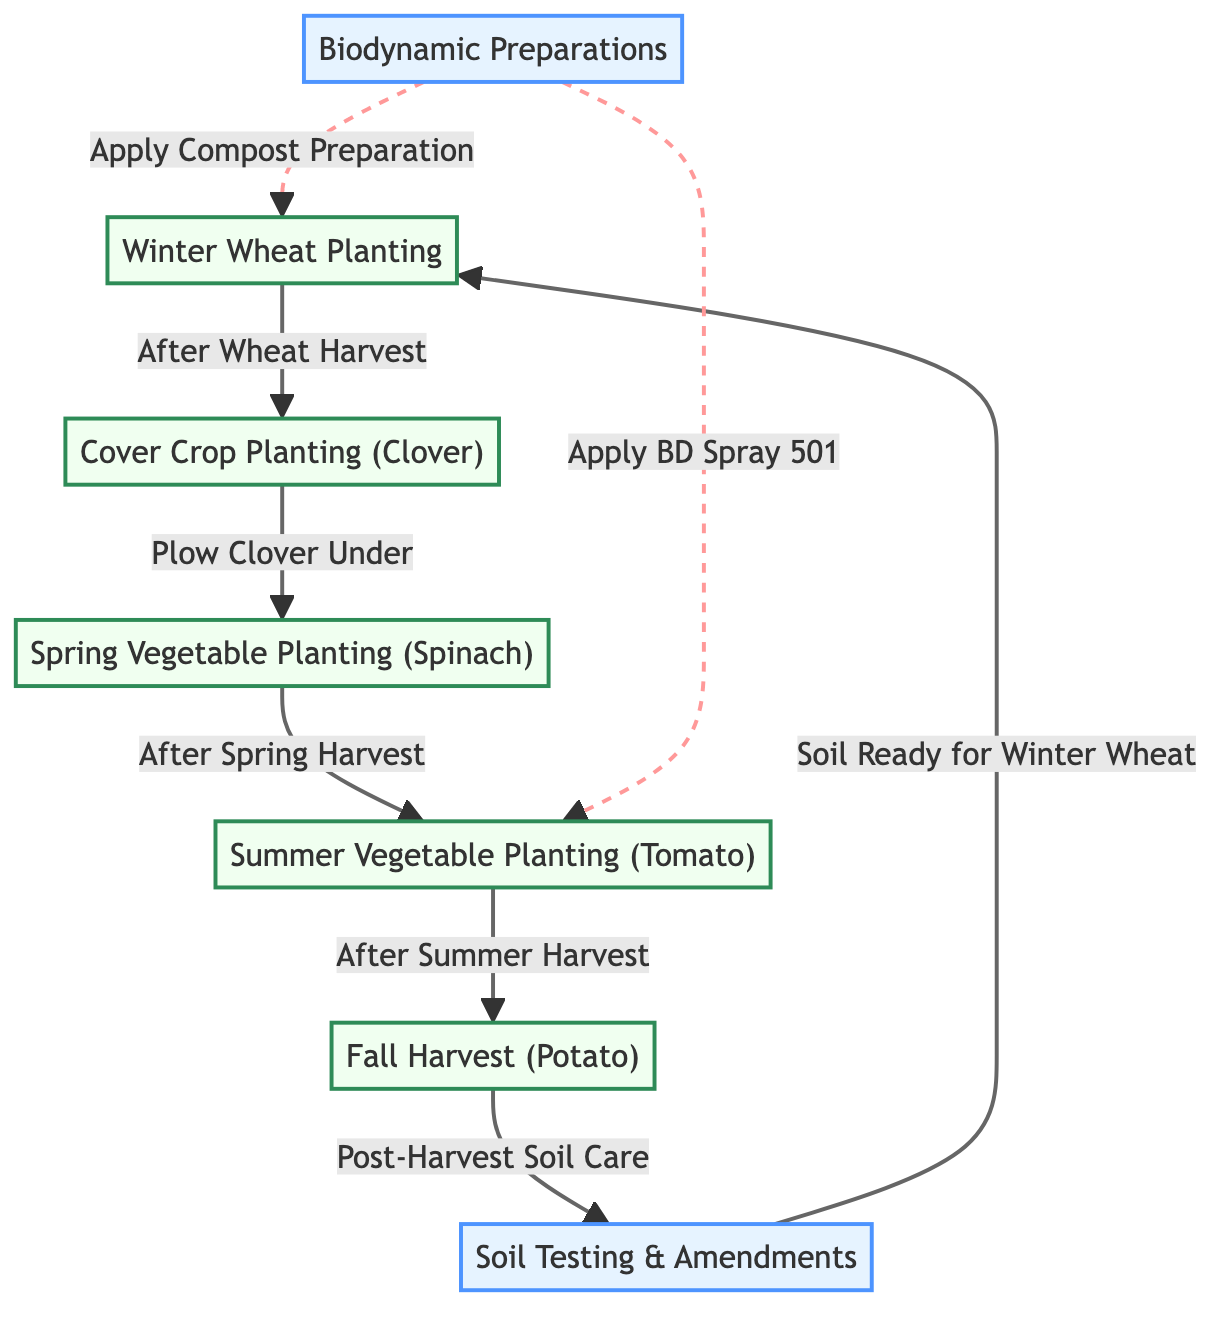What is the first crop planted in the rotation? The graph indicates that the first node in the cycle is "Winter Wheat Planting," which appears at the beginning of the flow.
Answer: Winter Wheat Planting How many nodes are there in the diagram? Counting all unique nodes presented in the data, we see there are seven nodes.
Answer: 7 What follows "Cover Crop Planting (Clover)" in the sequence? The directed edge labeled "Plow Clover Under" leads from "Cover Crop Planting (Clover)" to "Spring Vegetable Planting (Spinach)," indicating this is the next step.
Answer: Spring Vegetable Planting (Spinach) What is applied after "Summer Vegetable Planting (Tomato)"? Based on the directed edge labeled "After Summer Harvest," it transitions to "Fall Harvest (Potato)," indicating this is the subsequent action.
Answer: Fall Harvest (Potato) Identify the preparation step related to soil care. The directed edge labeled "Post-Harvest Soil Care" connects "Fall Harvest (Potato)" to "Soil Testing & Amendments," which is the preparation step focused on soil health.
Answer: Soil Testing & Amendments Which crop benefits from the biodynamic spray? The edge labeled "Apply BD Spray 501" indicates that "Summer Vegetable Planting (Tomato)" is the crop that receives this application.
Answer: Summer Vegetable Planting (Tomato) What is the final step before returning to "Winter Wheat Planting"? The cycle returns to "Winter Wheat Planting" after "Soil Testing & Amendments," based on the directed edge indicating readiness for planting.
Answer: Soil Testing & Amendments How many edges are directed toward the "Biodynamic Preparations" node? Observing the directed edges, "Biodynamic Preparations" only has two directed edges leading from it to "Winter Wheat Planting" and "Summer Vegetable Planting (Tomato)."
Answer: 2 What soil condition follows after the fall harvest? "Post-Harvest Soil Care" is the subsequent step following the "Fall Harvest (Potato)," focused on maintaining soil health after the harvest.
Answer: Post-Harvest Soil Care 